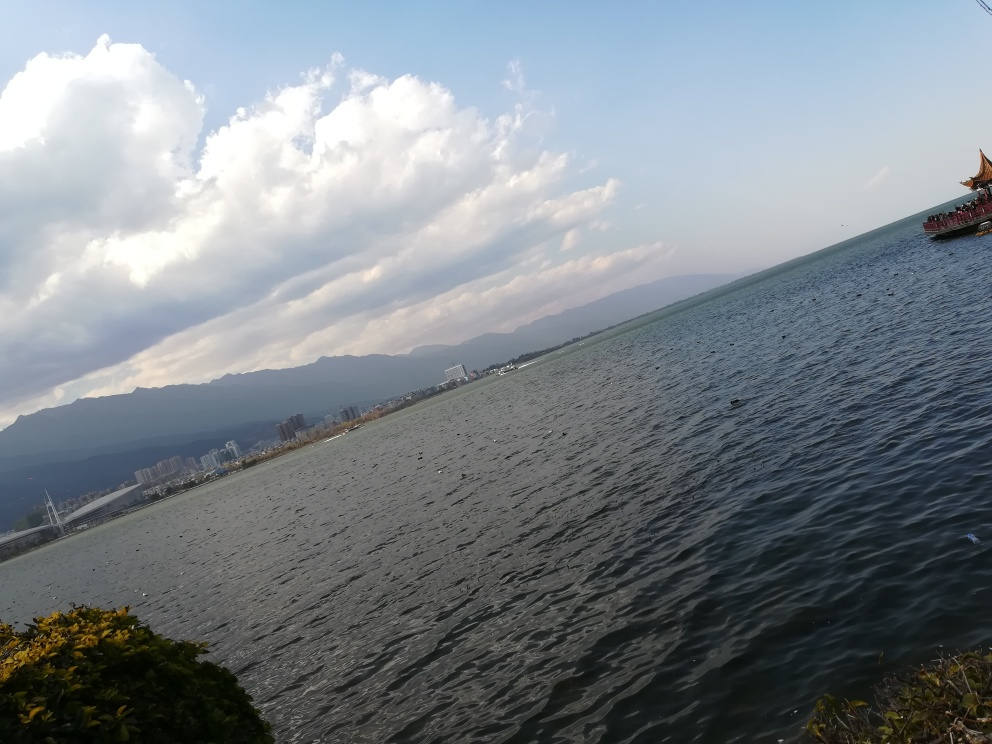Can you describe the weather conditions in this image? The weather appears partially cloudy with large cumulus clouds in the sky, suggesting it is a partly sunny day with no immediate signs of rainfall. 